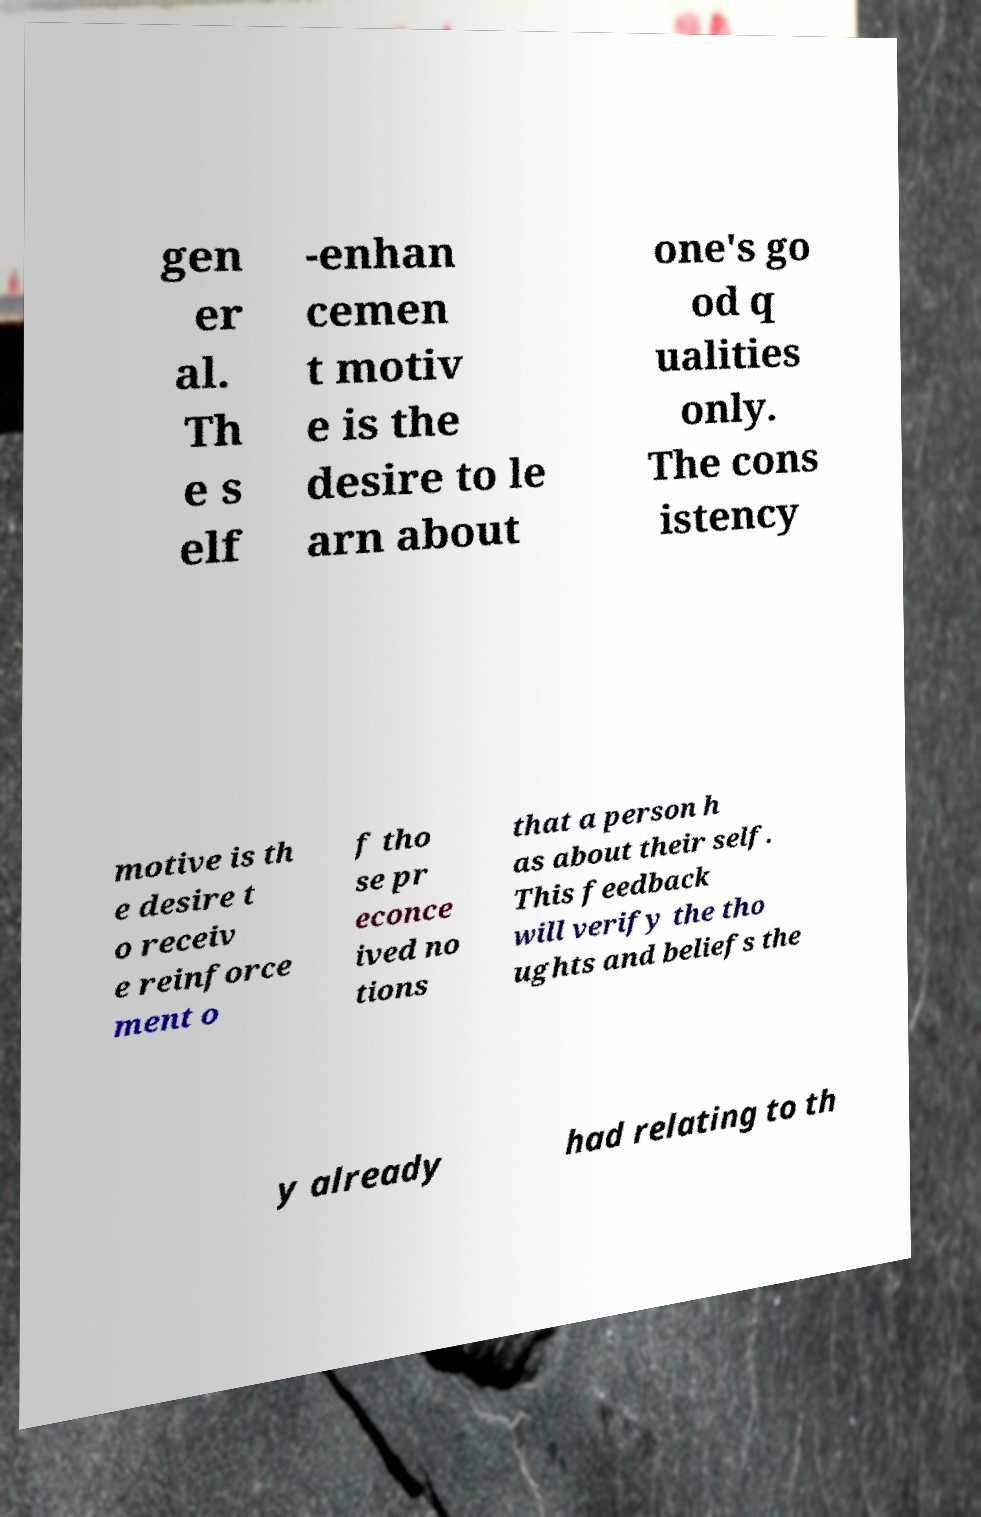Please identify and transcribe the text found in this image. gen er al. Th e s elf -enhan cemen t motiv e is the desire to le arn about one's go od q ualities only. The cons istency motive is th e desire t o receiv e reinforce ment o f tho se pr econce ived no tions that a person h as about their self. This feedback will verify the tho ughts and beliefs the y already had relating to th 